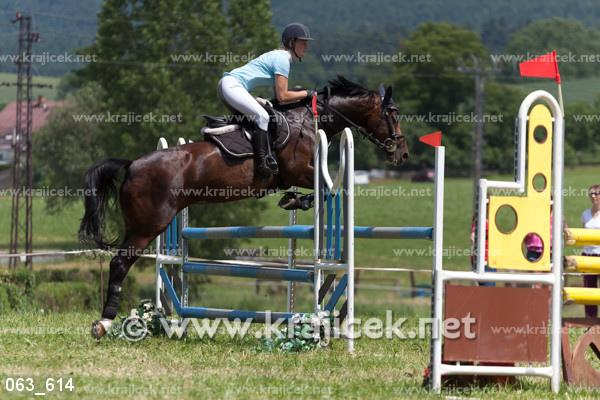What is this horse practicing? jumping 